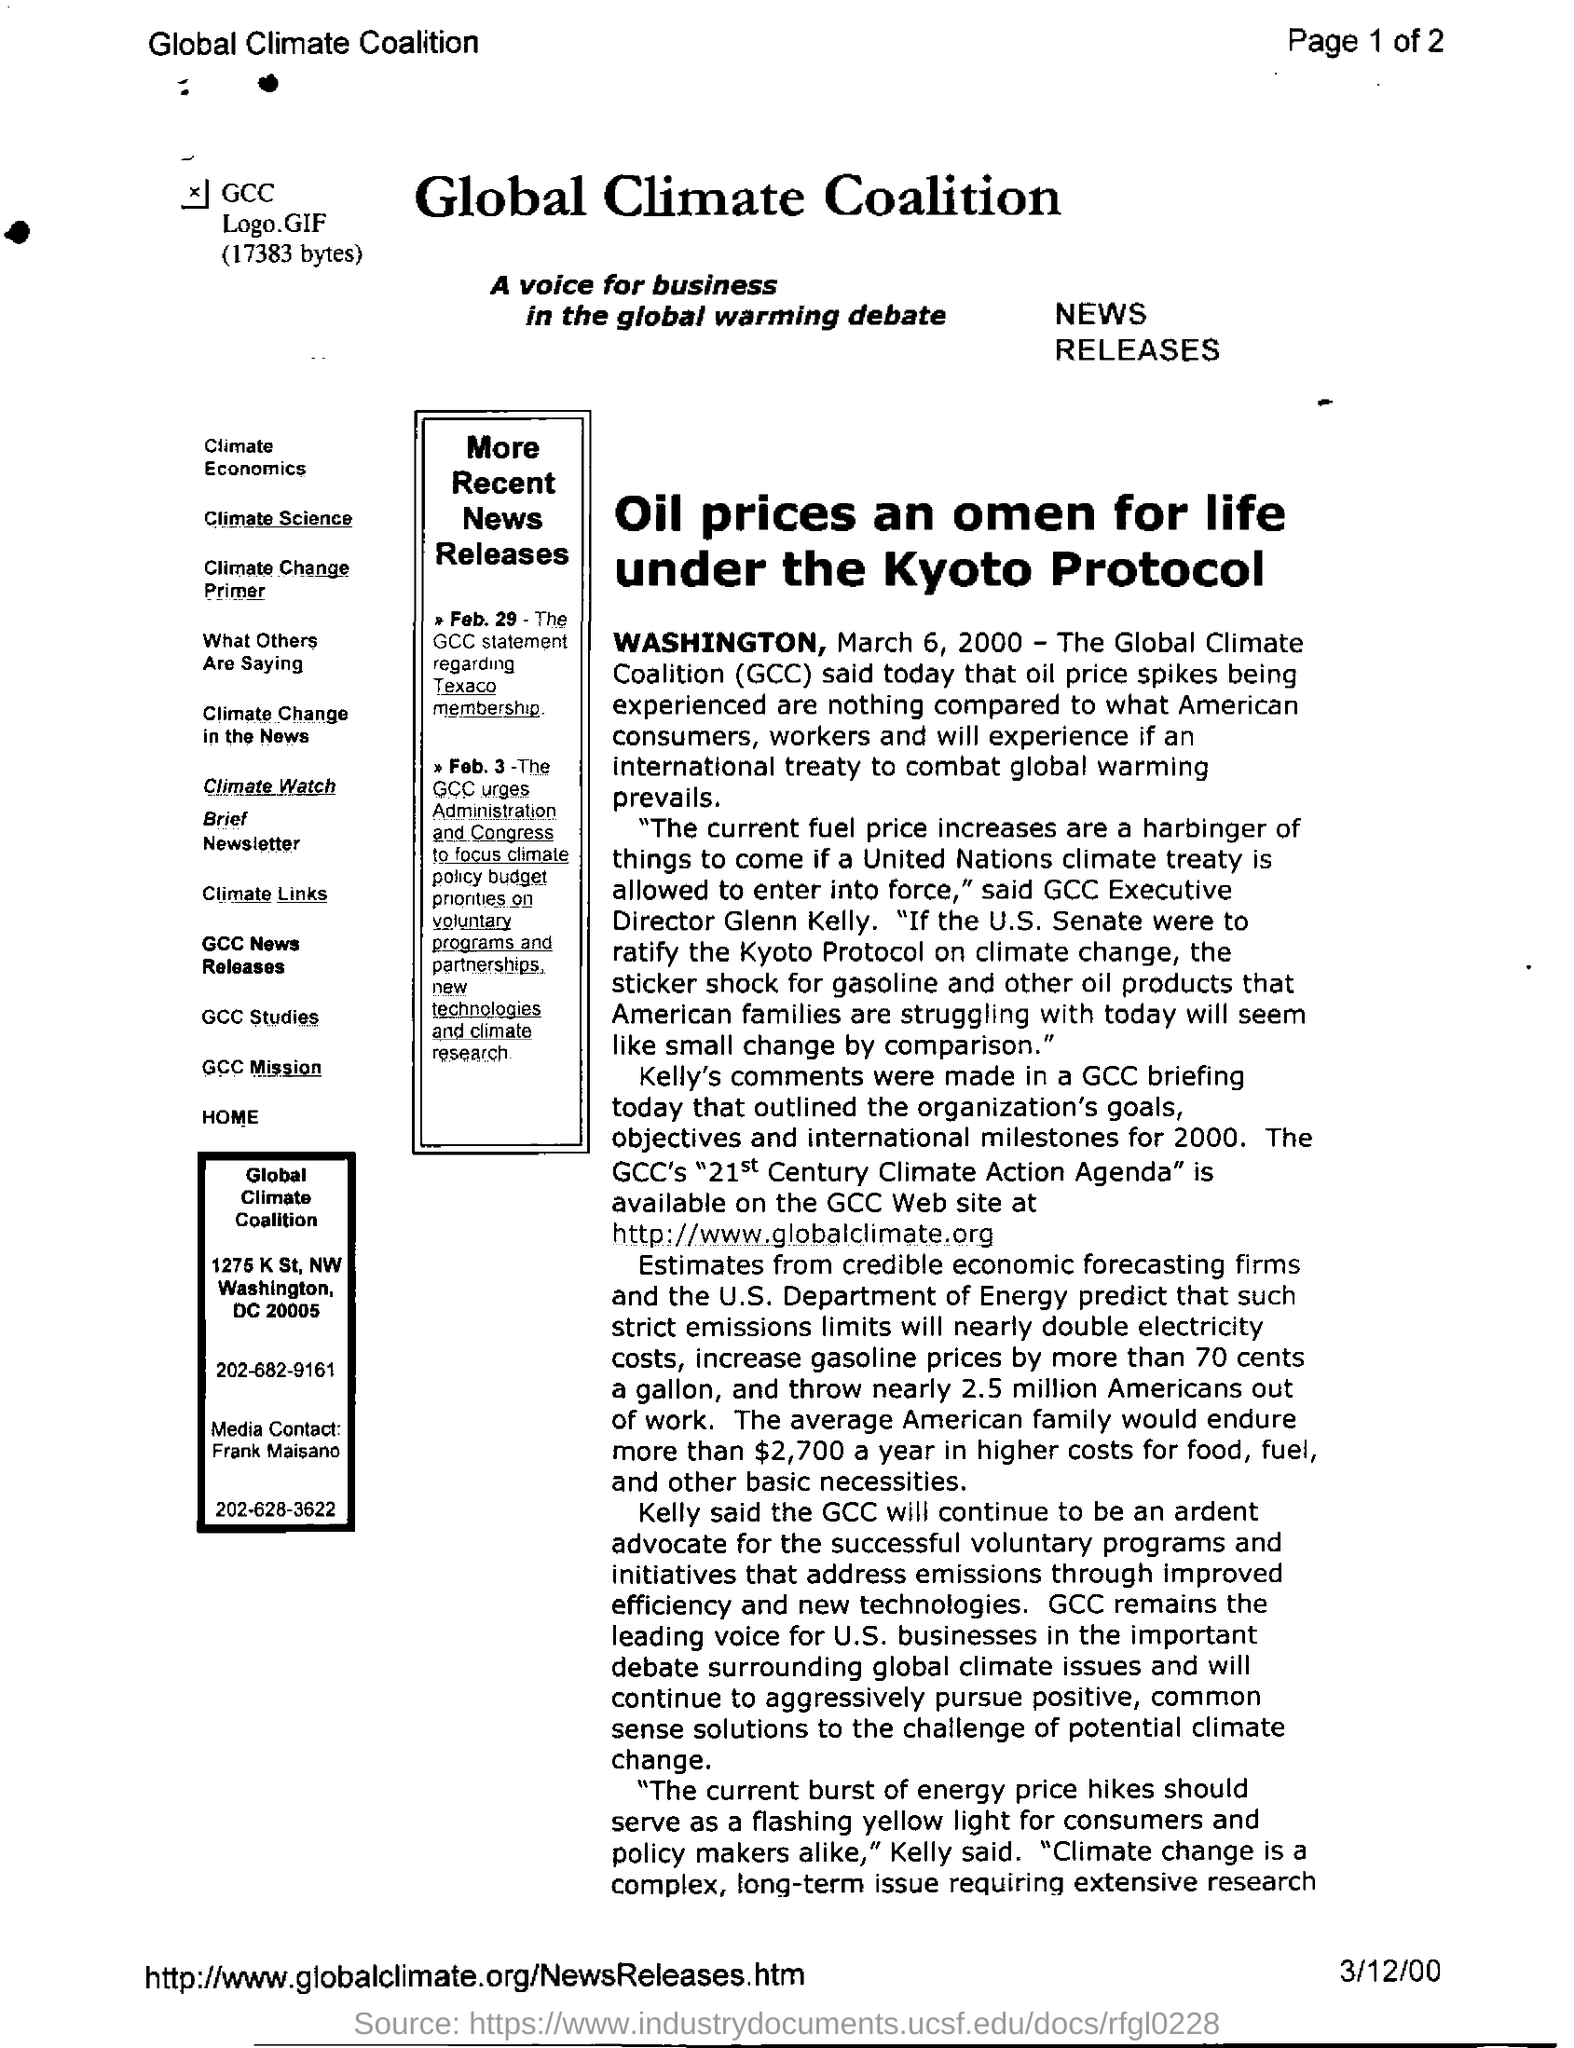Specify some key components in this picture. The full form of GCC is the Global Climate Coalition, which is a group that focuses on addressing global climate change. 